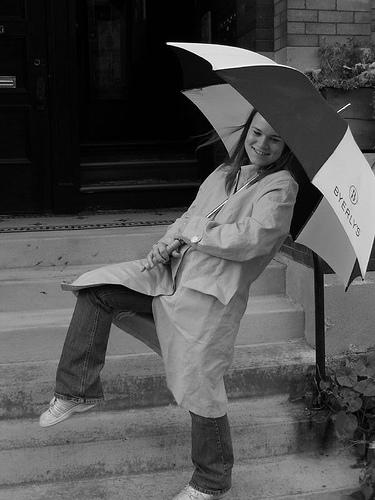How long is her hair?
Quick response, please. Mid length. What color are the girl's shoes?
Keep it brief. White. What is this person holding?
Answer briefly. Umbrella. What is the word on the umbrella?
Short answer required. Byerly's. What is the company name on the umbrella?
Short answer required. Byerly's. Is this person carrying a camera?
Give a very brief answer. No. Is this pic color or white and black?
Answer briefly. White and black. Did she hit a softball?
Keep it brief. No. 